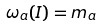Convert formula to latex. <formula><loc_0><loc_0><loc_500><loc_500>\omega _ { a } ( I ) = m _ { a }</formula> 